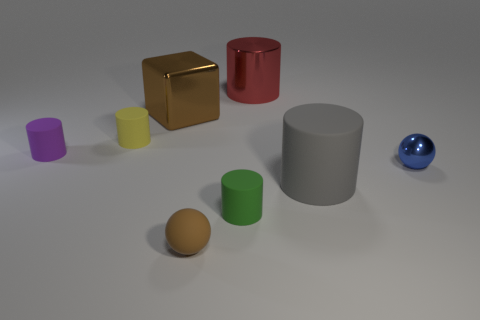There is a matte cylinder that is in front of the big gray cylinder; how many small yellow cylinders are in front of it?
Ensure brevity in your answer.  0. What number of brown things are the same material as the tiny yellow cylinder?
Your answer should be very brief. 1. How many small things are gray objects or brown rubber cylinders?
Your answer should be very brief. 0. The small matte thing that is both behind the brown ball and in front of the blue metal sphere has what shape?
Your response must be concise. Cylinder. Is the purple cylinder made of the same material as the tiny yellow object?
Give a very brief answer. Yes. What color is the metallic sphere that is the same size as the yellow object?
Offer a very short reply. Blue. The tiny object that is both right of the brown matte thing and on the left side of the red metal object is what color?
Make the answer very short. Green. There is a object that is the same color as the large cube; what size is it?
Provide a succinct answer. Small. The tiny object that is the same color as the cube is what shape?
Your answer should be compact. Sphere. What is the size of the matte object that is to the left of the small yellow object behind the small rubber cylinder to the right of the tiny brown sphere?
Provide a short and direct response. Small. 